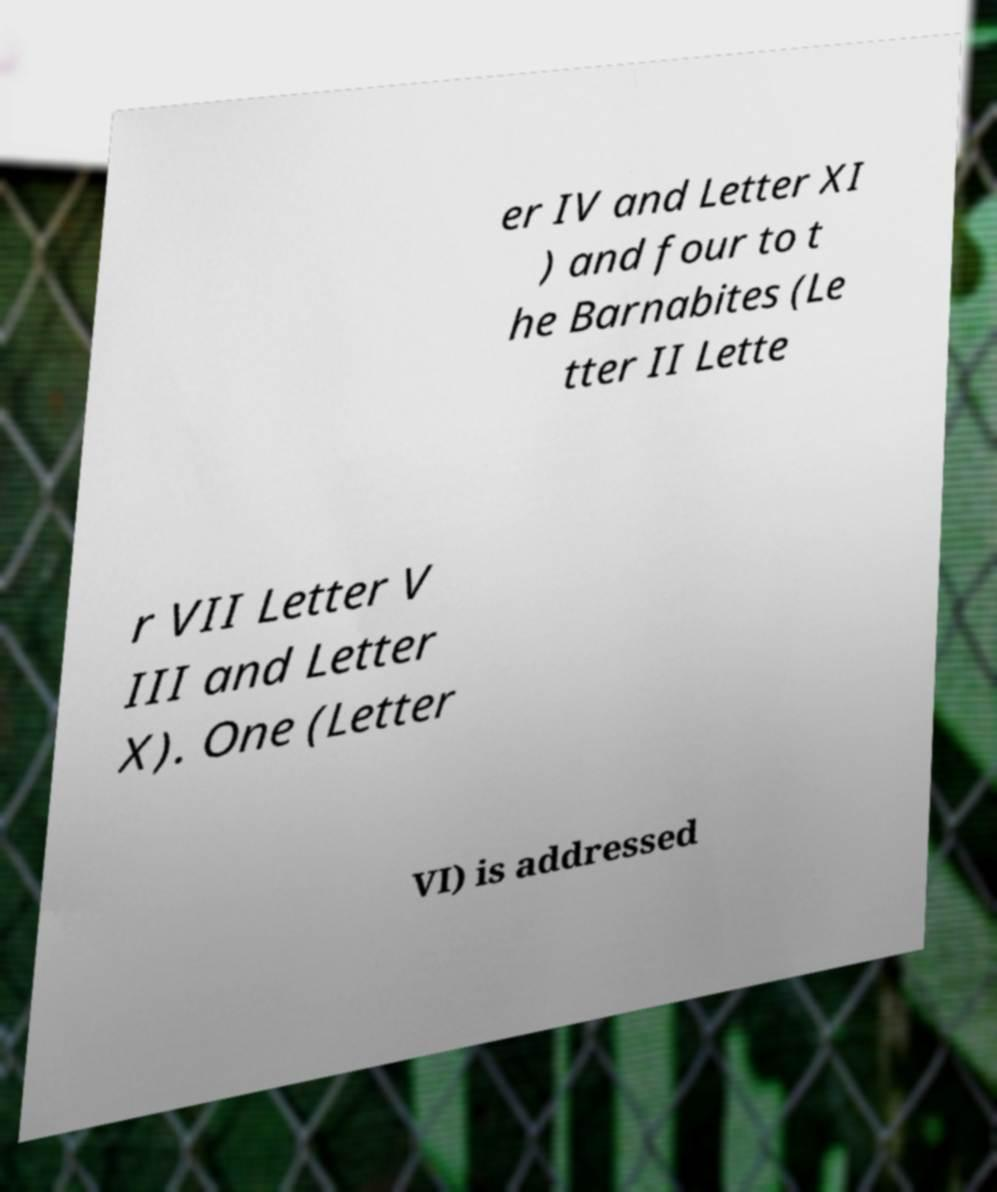For documentation purposes, I need the text within this image transcribed. Could you provide that? er IV and Letter XI ) and four to t he Barnabites (Le tter II Lette r VII Letter V III and Letter X). One (Letter VI) is addressed 